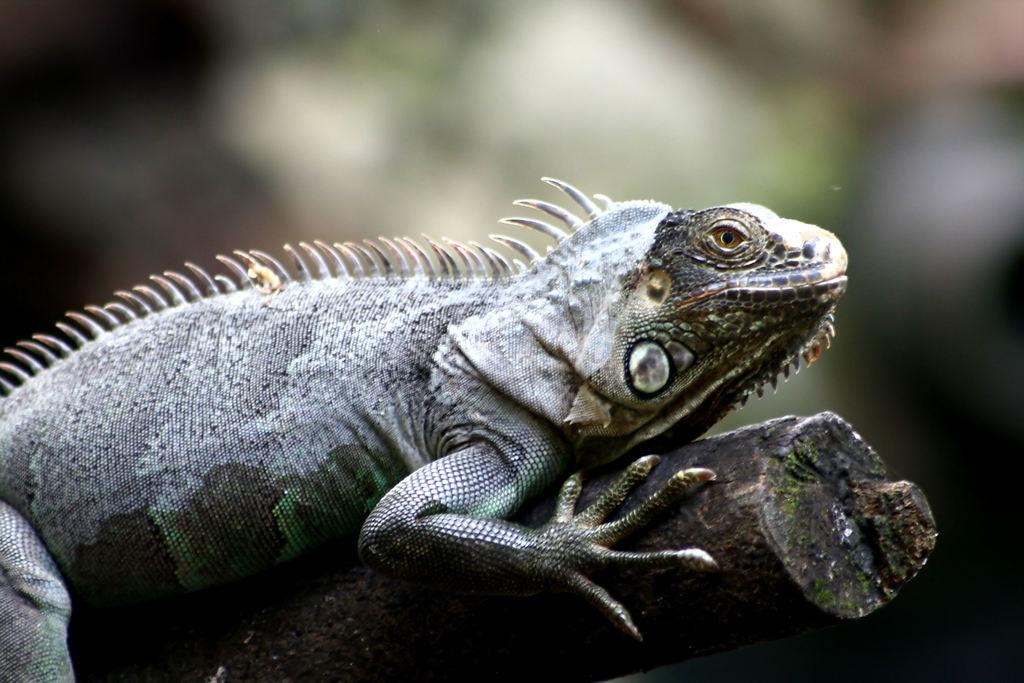What type of animal is present in the image? There is a grey-colored lizard in the image. How many legs does the giraffe have in the image? There is no giraffe present in the image, and therefore no legs can be counted. What is the lizard holding in its hand in the image? Lizards do not have hands, as they are reptiles with four legs. 